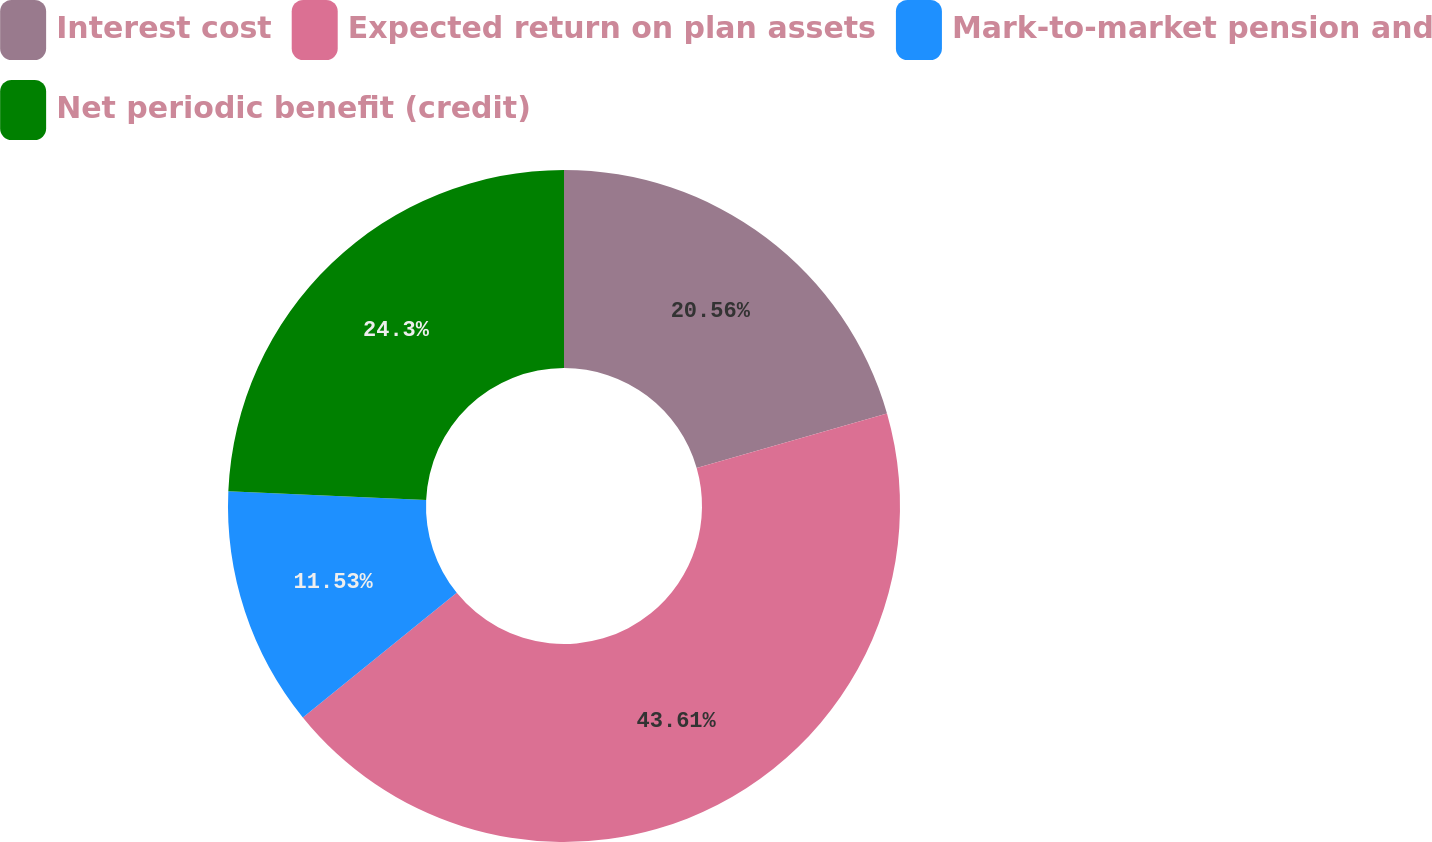Convert chart to OTSL. <chart><loc_0><loc_0><loc_500><loc_500><pie_chart><fcel>Interest cost<fcel>Expected return on plan assets<fcel>Mark-to-market pension and<fcel>Net periodic benefit (credit)<nl><fcel>20.56%<fcel>43.61%<fcel>11.53%<fcel>24.3%<nl></chart> 